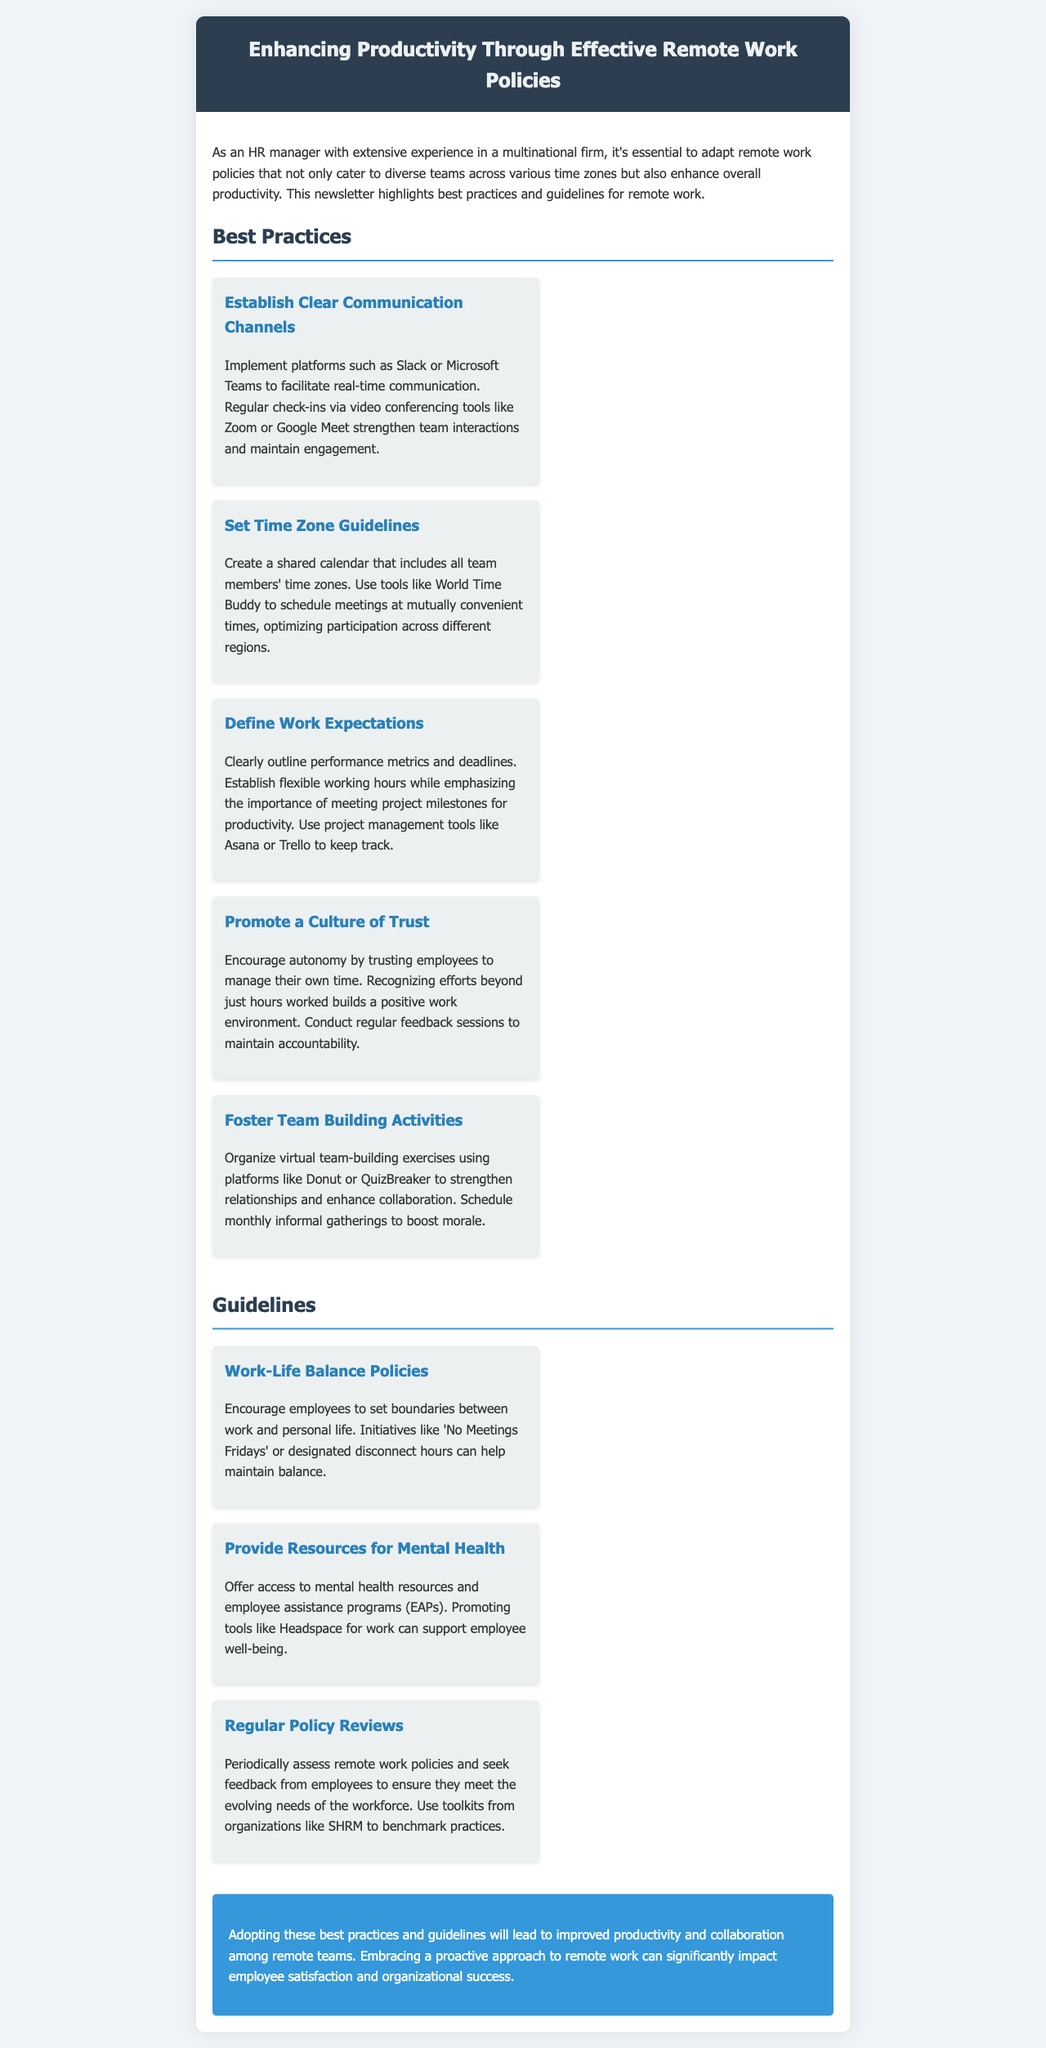What is the title of the newsletter? The title is prominently featured in the header section of the document.
Answer: Enhancing Productivity Through Effective Remote Work Policies What platform is suggested for real-time communication? The document mentions specific platforms for communication in the best practices section.
Answer: Slack or Microsoft Teams What is one tool recommended for scheduling across time zones? The text indicates tools suitable for managing time zones during scheduling in the best practices section.
Answer: World Time Buddy What is one key aspect of work expectations in remote work? The document outlines expectations regarding performance metrics in the best practices section.
Answer: Clear performance metrics What is one initiative suggested for maintaining work-life balance? The guidelines section emphasizes specific initiatives to help employees balance work and personal life.
Answer: No Meetings Fridays How often should remote work policies be reviewed? The guidelines mention the frequency of policy assessments in the context of evolving workforce needs.
Answer: Periodically What color is used for the conclusion section? The conclusion section is described with its distinct background color within the document.
Answer: Blue What is the main goal of adopting the best practices? The document concludes with the intended outcome of implementing the suggested practices.
Answer: Improved productivity and collaboration 